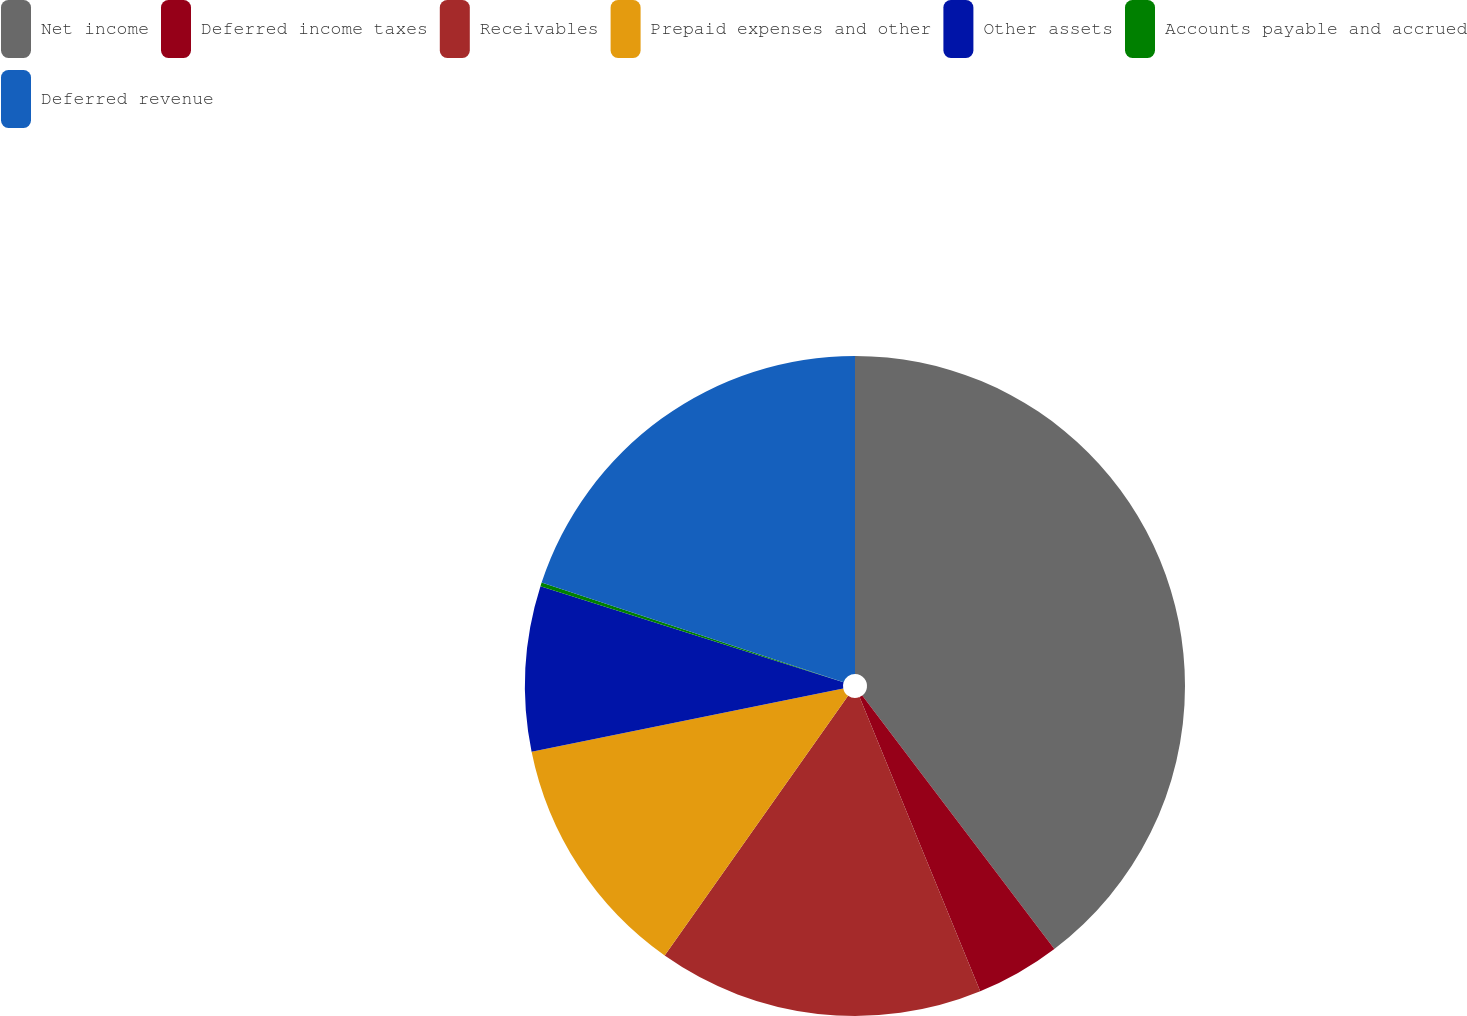<chart> <loc_0><loc_0><loc_500><loc_500><pie_chart><fcel>Net income<fcel>Deferred income taxes<fcel>Receivables<fcel>Prepaid expenses and other<fcel>Other assets<fcel>Accounts payable and accrued<fcel>Deferred revenue<nl><fcel>39.68%<fcel>4.13%<fcel>15.98%<fcel>12.03%<fcel>8.08%<fcel>0.18%<fcel>19.93%<nl></chart> 